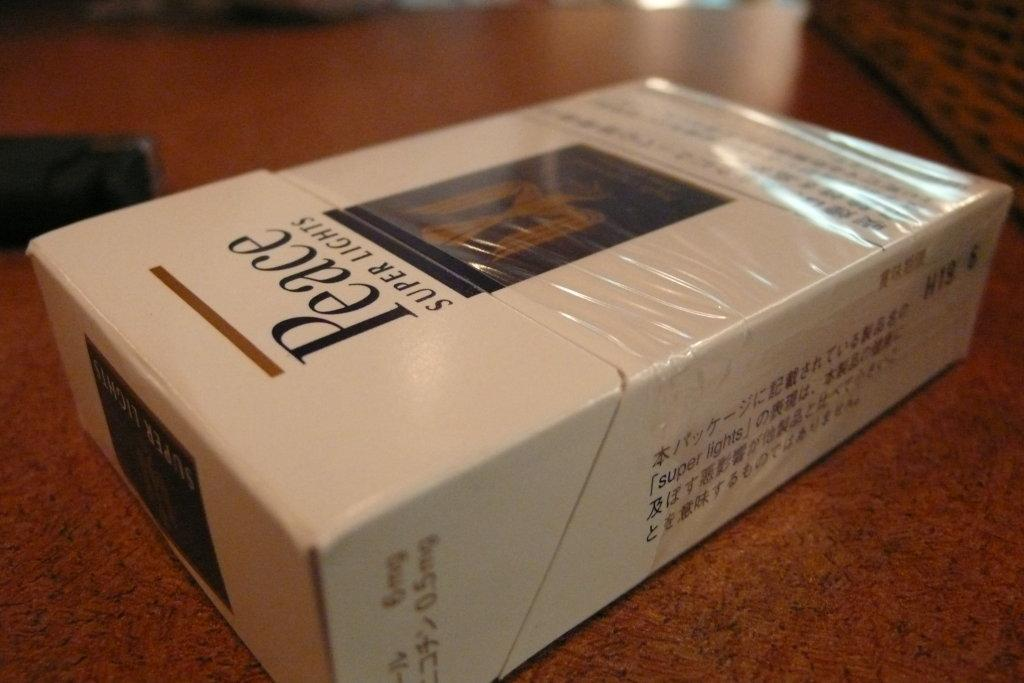Provide a one-sentence caption for the provided image. Super Lights cigarettes are in a box with the word, "Peace", in large letters on the front of the box. 